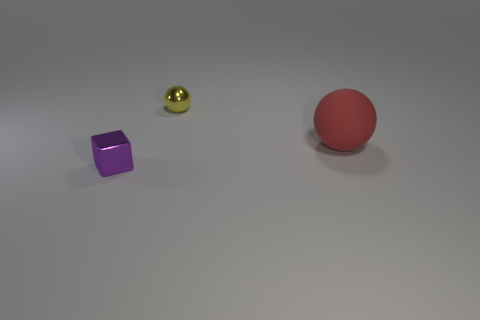Is there another object of the same shape as the small yellow object?
Provide a short and direct response. Yes. The object that is behind the big red matte ball has what shape?
Provide a succinct answer. Sphere. What number of small brown spheres are there?
Provide a short and direct response. 0. The tiny sphere that is made of the same material as the small cube is what color?
Give a very brief answer. Yellow. How many small objects are metallic things or yellow matte things?
Make the answer very short. 2. What number of large red spheres are right of the small yellow object?
Your response must be concise. 1. What is the color of the other thing that is the same shape as the matte thing?
Provide a short and direct response. Yellow. What number of shiny things are purple objects or small balls?
Your response must be concise. 2. Is there a metal thing that is behind the small thing right of the tiny metal object in front of the red ball?
Offer a very short reply. No. What is the color of the tiny shiny cube?
Offer a terse response. Purple. 